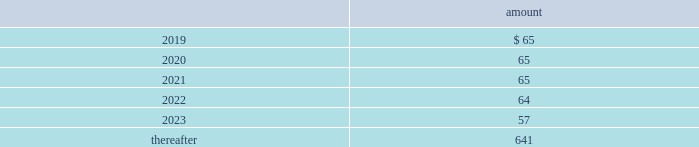Totaled $ 12 million , $ 13 million and $ 9 million for 2018 , 2017 and 2016 , respectively .
All of the company 2019s contributions are invested in one or more funds at the direction of the employees .
Note 16 : commitments and contingencies commitments have been made in connection with certain construction programs .
The estimated capital expenditures required under legal and binding contractual obligations amounted to $ 419 million as of december 31 , 2018 .
The company 2019s regulated subsidiaries maintain agreements with other water purveyors for the purchase of water to supplement their water supply .
The table provides the future annual commitments related to minimum quantities of purchased water having non-cancelable: .
The company enters into agreements for the provision of services to water and wastewater facilities for the united states military , municipalities and other customers .
See note 3 2014revenue recognition for additional information regarding the company 2019s performance obligations .
Contingencies the company is routinely involved in legal actions incident to the normal conduct of its business .
As of december 31 , 2018 , the company has accrued approximately $ 54 million of probable loss contingencies and has estimated that the maximum amount of losses associated with reasonably possible loss contingencies that can be reasonably estimated is $ 26 million .
For certain matters , claims and actions , the company is unable to estimate possible losses .
The company believes that damages or settlements , if any , recovered by plaintiffs in such matters , claims or actions , other than as described in this note 16 2014commitments and contingencies , will not have a material adverse effect on the company .
West virginia elk river freedom industries chemical spill on june 8 , 2018 , the u.s .
District court for the southern district of west virginia granted final approval of a settlement class and global class action settlement ( the 201csettlement 201d ) for all claims and potential claims by all putative class members ( collectively , the 201cplaintiffs 201d ) arising out of the january 2014 freedom industries , inc .
Chemical spill in west virginia .
The effective date of the settlement is july 16 , 2018 .
Under the terms and conditions of the settlement , west virginia-american water company ( 201cwvawc 201d ) and certain other company affiliated entities ( collectively , the 201camerican water defendants 201d ) did not admit , and will not admit , any fault or liability for any of the allegations made by the plaintiffs in any of the actions that were resolved .
Under federal class action rules , claimants had the right , until december 8 , 2017 , to elect to opt out of the final settlement .
Less than 100 of the 225000 estimated putative class members elected to opt out from the settlement , and these claimants will not receive any benefit from or be bound by the terms of the settlement .
In june 2018 , the company and its remaining non-participating general liability insurance carrier settled for a payment to the company of $ 20 million , out of a maximum of $ 25 million in potential coverage under the terms of the relevant policy , in exchange for a full release by the american water defendants of all claims against the insurance carrier related to the freedom industries chemical spill. .
What was the change in the amount of future annual commitments related to minimum quantities of purchased water between \\n2019 and 2020? 
Computations: (65 - 65)
Answer: 0.0. 